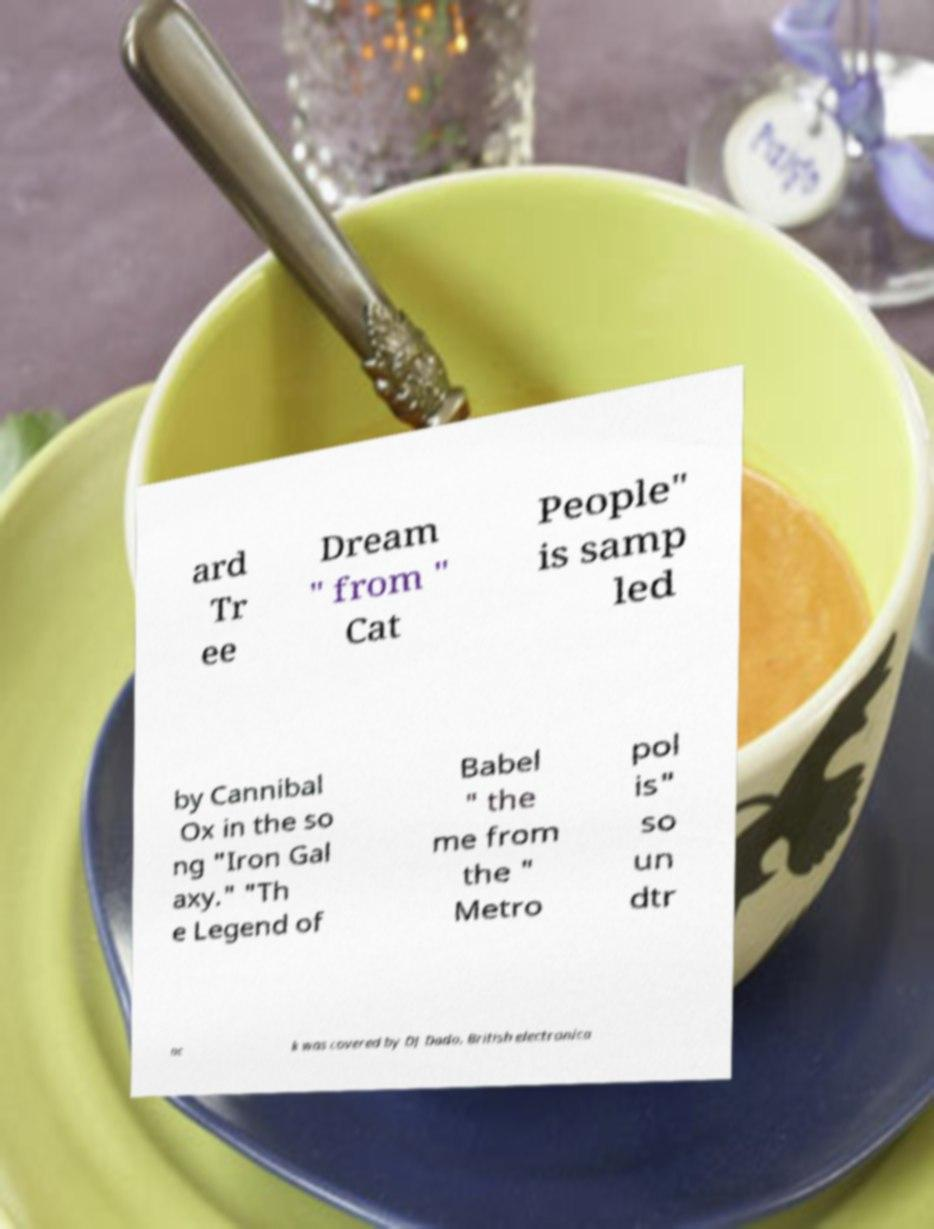There's text embedded in this image that I need extracted. Can you transcribe it verbatim? ard Tr ee Dream " from " Cat People" is samp led by Cannibal Ox in the so ng "Iron Gal axy." "Th e Legend of Babel " the me from the " Metro pol is" so un dtr ac k was covered by DJ Dado. British electronica 